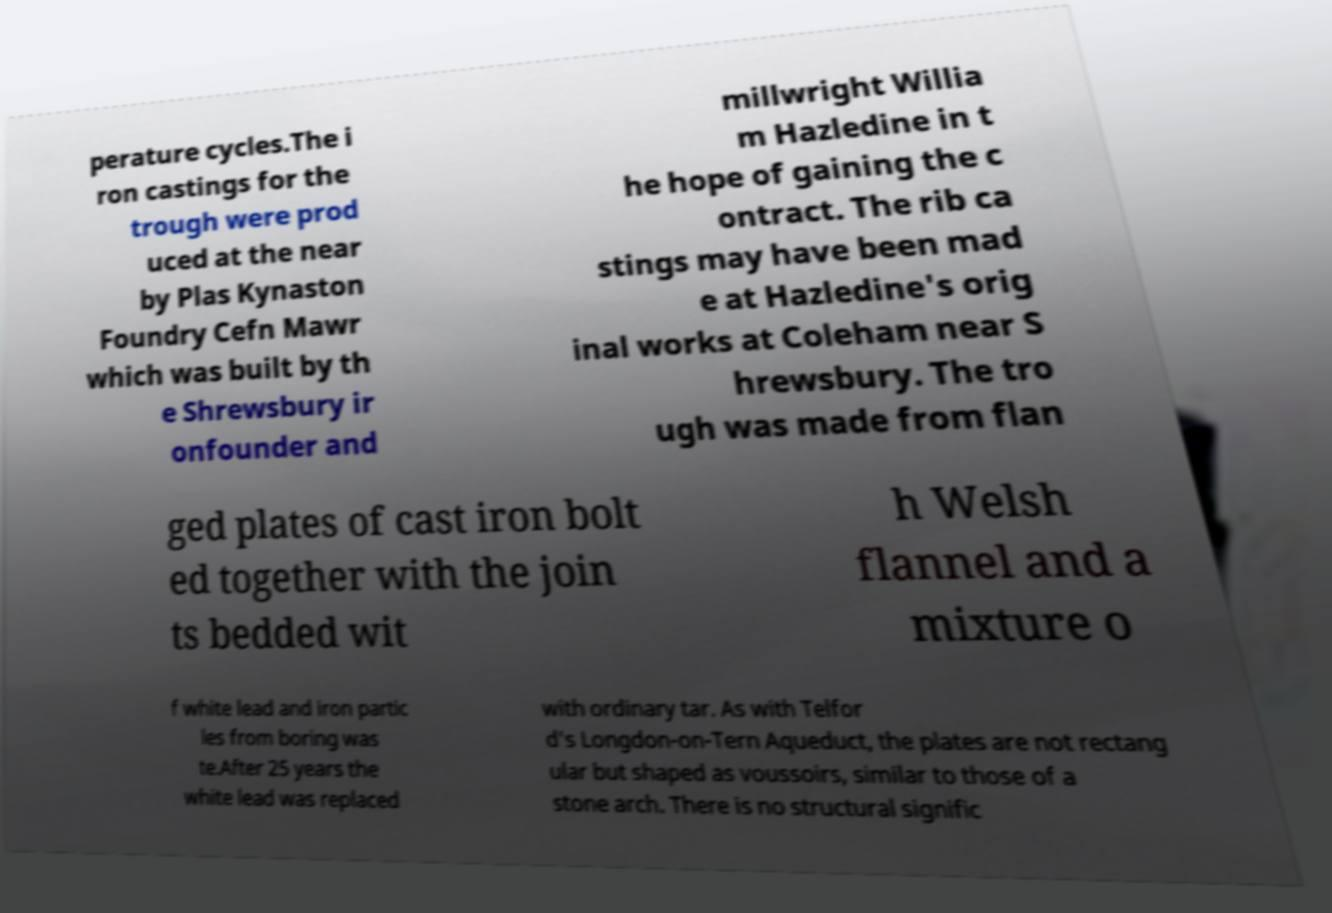Please read and relay the text visible in this image. What does it say? perature cycles.The i ron castings for the trough were prod uced at the near by Plas Kynaston Foundry Cefn Mawr which was built by th e Shrewsbury ir onfounder and millwright Willia m Hazledine in t he hope of gaining the c ontract. The rib ca stings may have been mad e at Hazledine's orig inal works at Coleham near S hrewsbury. The tro ugh was made from flan ged plates of cast iron bolt ed together with the join ts bedded wit h Welsh flannel and a mixture o f white lead and iron partic les from boring was te.After 25 years the white lead was replaced with ordinary tar. As with Telfor d's Longdon-on-Tern Aqueduct, the plates are not rectang ular but shaped as voussoirs, similar to those of a stone arch. There is no structural signific 